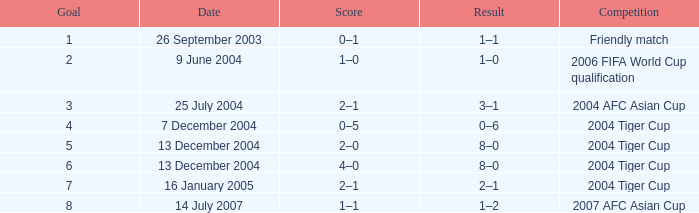Which date has 3 as the goal? 25 July 2004. 